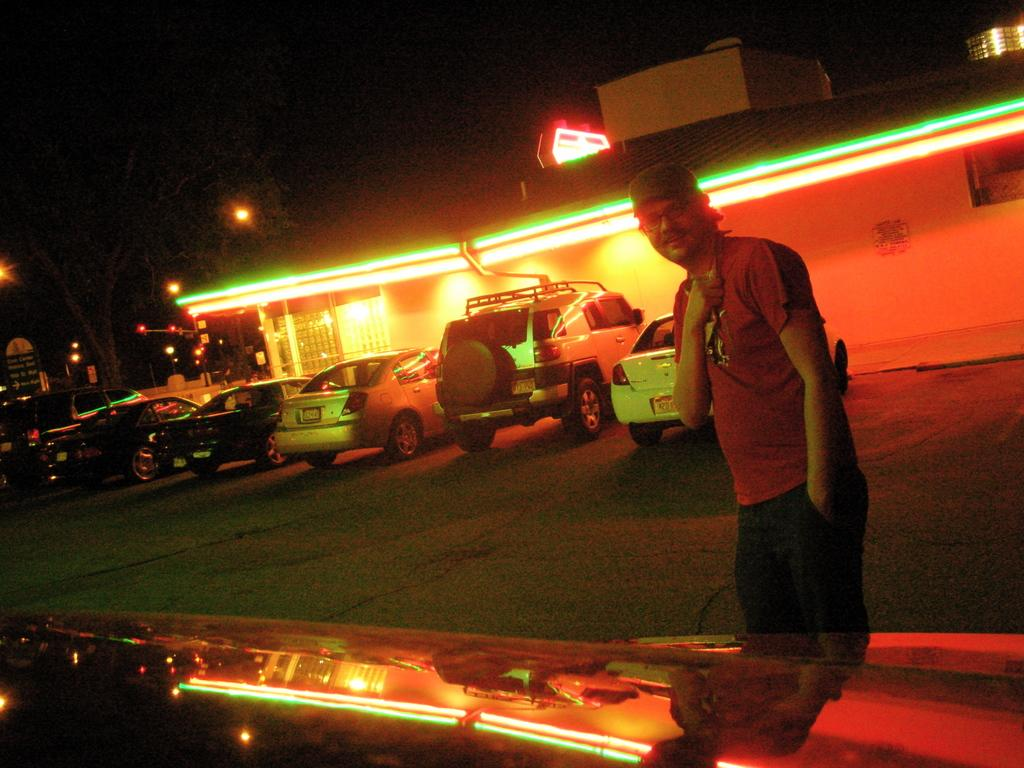What is located on the right side of the image? There is a man on the right side of the image. What can be seen in the background of the image? There are vehicles, lights, and a building in the background of the image. What is on the left side of the image? There are trees and a board on the left side of the image. What is the man's opinion about the chess game in the image? There is no chess game present in the image, and therefore no such discussion can be observed. Can you tell me how the man is smiling in the image? The man's facial expression is not mentioned in the provided facts, so it cannot be determined whether he is smiling or not. 